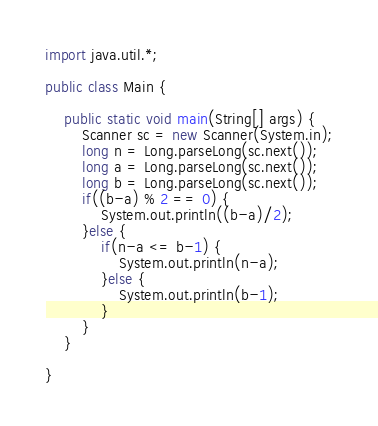Convert code to text. <code><loc_0><loc_0><loc_500><loc_500><_Java_>import java.util.*;
 
public class Main {
 
    public static void main(String[] args) {
        Scanner sc = new Scanner(System.in);
        long n = Long.parseLong(sc.next());
        long a = Long.parseLong(sc.next());
        long b = Long.parseLong(sc.next());
        if((b-a) % 2 == 0) {
            System.out.println((b-a)/2);
        }else {
            if(n-a <= b-1) {
                System.out.println(n-a);
            }else {
                System.out.println(b-1);
            }
        }
    }
 
}</code> 